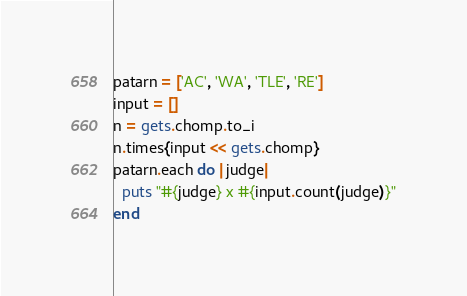<code> <loc_0><loc_0><loc_500><loc_500><_Ruby_>patarn = ['AC', 'WA', 'TLE', 'RE']
input = []
n = gets.chomp.to_i
n.times{input << gets.chomp}
patarn.each do |judge|
  puts "#{judge} x #{input.count(judge)}"
end</code> 